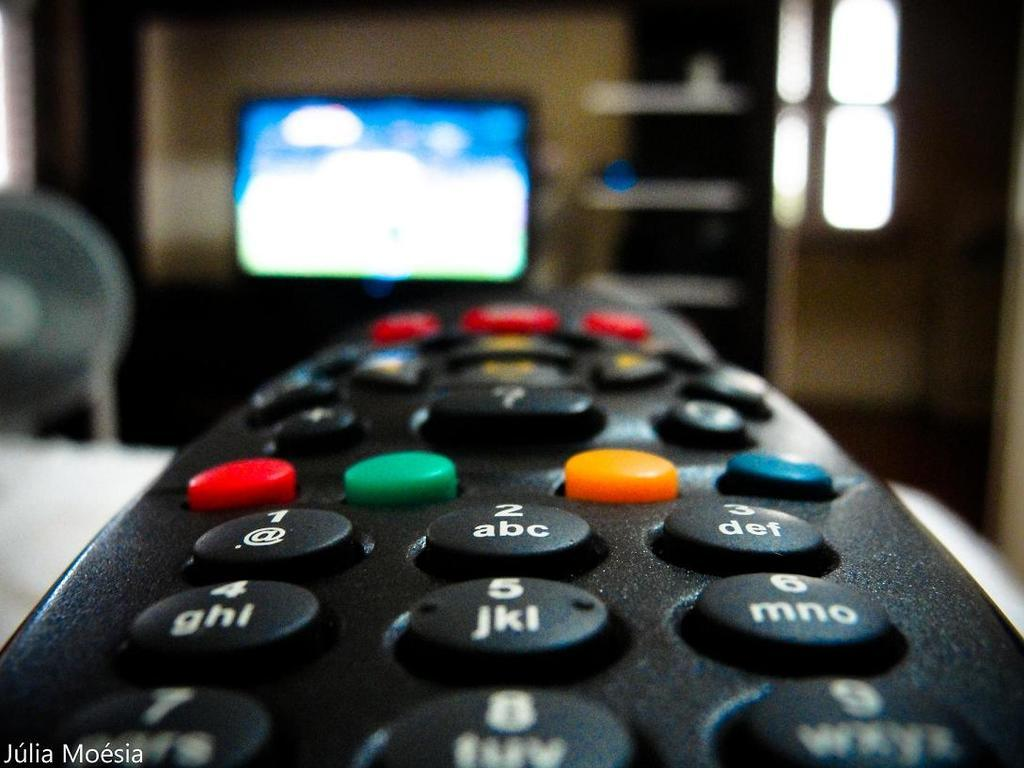<image>
Describe the image concisely. A photographed remote that says 'julia moesia' at the bottom of the picture 